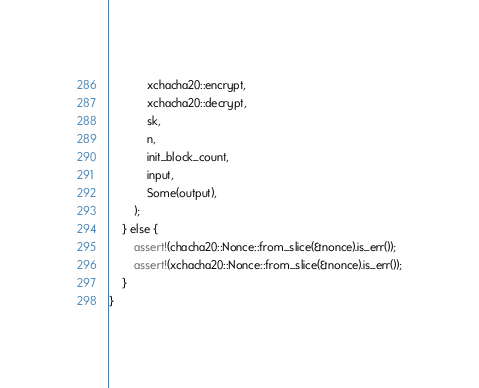<code> <loc_0><loc_0><loc_500><loc_500><_Rust_>            xchacha20::encrypt,
            xchacha20::decrypt,
            sk,
            n,
            init_block_count,
            input,
            Some(output),
        );
    } else {
        assert!(chacha20::Nonce::from_slice(&nonce).is_err());
        assert!(xchacha20::Nonce::from_slice(&nonce).is_err());
    }
}
</code> 